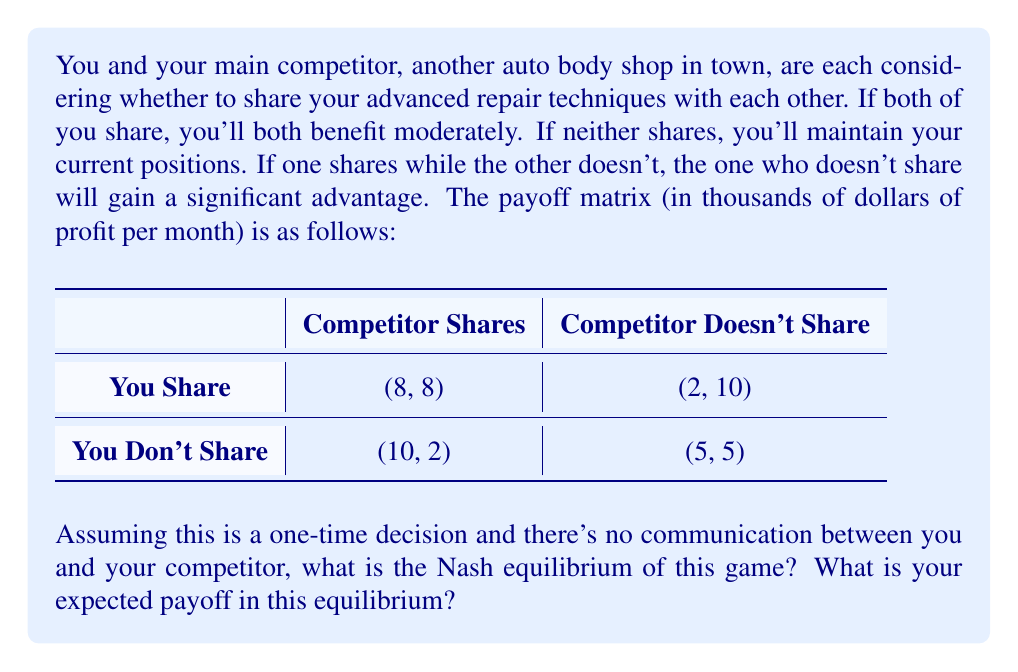Give your solution to this math problem. To solve this prisoner's dilemma scenario, we need to identify the Nash equilibrium. A Nash equilibrium is a situation where neither player can unilaterally improve their outcome by changing their strategy.

Let's analyze each player's best response to the other's actions:

1. If the competitor shares:
   - If you share, your payoff is 8
   - If you don't share, your payoff is 10
   - Your best response is to not share

2. If the competitor doesn't share:
   - If you share, your payoff is 2
   - If you don't share, your payoff is 5
   - Your best response is to not share

We can see that regardless of what the competitor does, your best strategy is to not share. The same analysis applies to your competitor.

Therefore, the Nash equilibrium is (Don't Share, Don't Share). This is a dominant strategy equilibrium, as not sharing is the best strategy for both players regardless of what the other does.

In this equilibrium, both players choose not to share their advanced repair techniques. The payoff for each player in this equilibrium is 5 thousand dollars of profit per month.

This outcome illustrates the classic prisoner's dilemma. Although both players would be better off if they both shared (with payoffs of 8 each), the equilibrium results in a suboptimal outcome where neither shares.
Answer: The Nash equilibrium is (Don't Share, Don't Share), with an expected payoff of $5,000 per month for each player. 